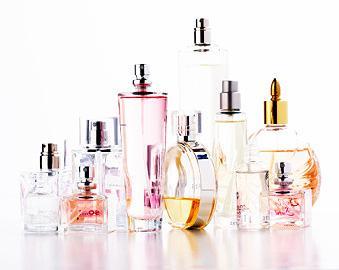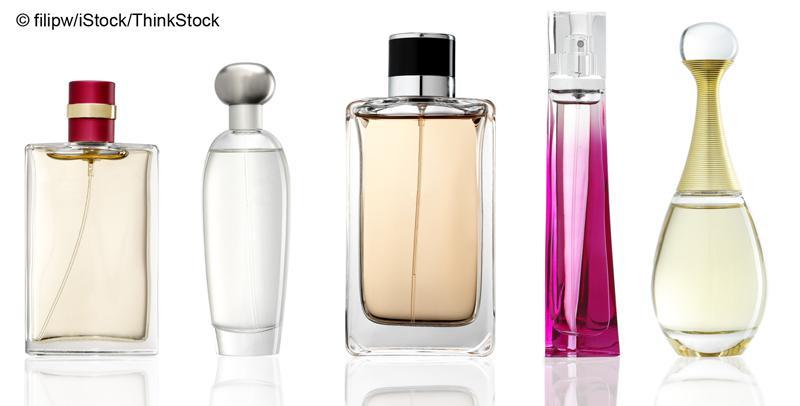The first image is the image on the left, the second image is the image on the right. Considering the images on both sides, is "None of the fragrances are seen with their box." valid? Answer yes or no. Yes. The first image is the image on the left, the second image is the image on the right. Considering the images on both sides, is "There are at least five bottles of perfume with one square bottle that has a red top with a gold stripe." valid? Answer yes or no. Yes. 